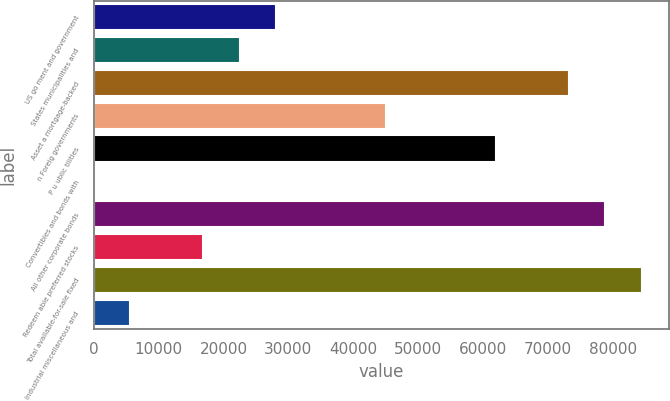<chart> <loc_0><loc_0><loc_500><loc_500><bar_chart><fcel>US go ment and government<fcel>States municipalities and<fcel>Asset a mortgage-backed<fcel>n Foreig governments<fcel>P u ublic tilities<fcel>Convertibles and bonds with<fcel>All other corporate bonds<fcel>Redeem able preferred stocks<fcel>Total available-for-sale fixed<fcel>Industrial miscellaneous and<nl><fcel>28142.5<fcel>22515.8<fcel>73156.1<fcel>45022.6<fcel>61902.7<fcel>9<fcel>78782.8<fcel>16889.1<fcel>84409.5<fcel>5635.7<nl></chart> 